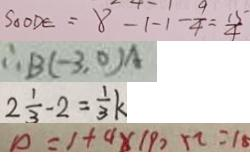Convert formula to latex. <formula><loc_0><loc_0><loc_500><loc_500>S _ { \Delta } O D E = 8 - 1 - 1 - \frac { 9 } { 4 } = \frac { 1 5 } { 4 } 
 \therefore B ( - 3 , 0 ) A 
 2 \frac { 1 } { 3 } - 2 = \frac { 1 } { 3 } k 
 0 = 1 + 4 \times 1 9 0 \times 2 = 1 8</formula> 